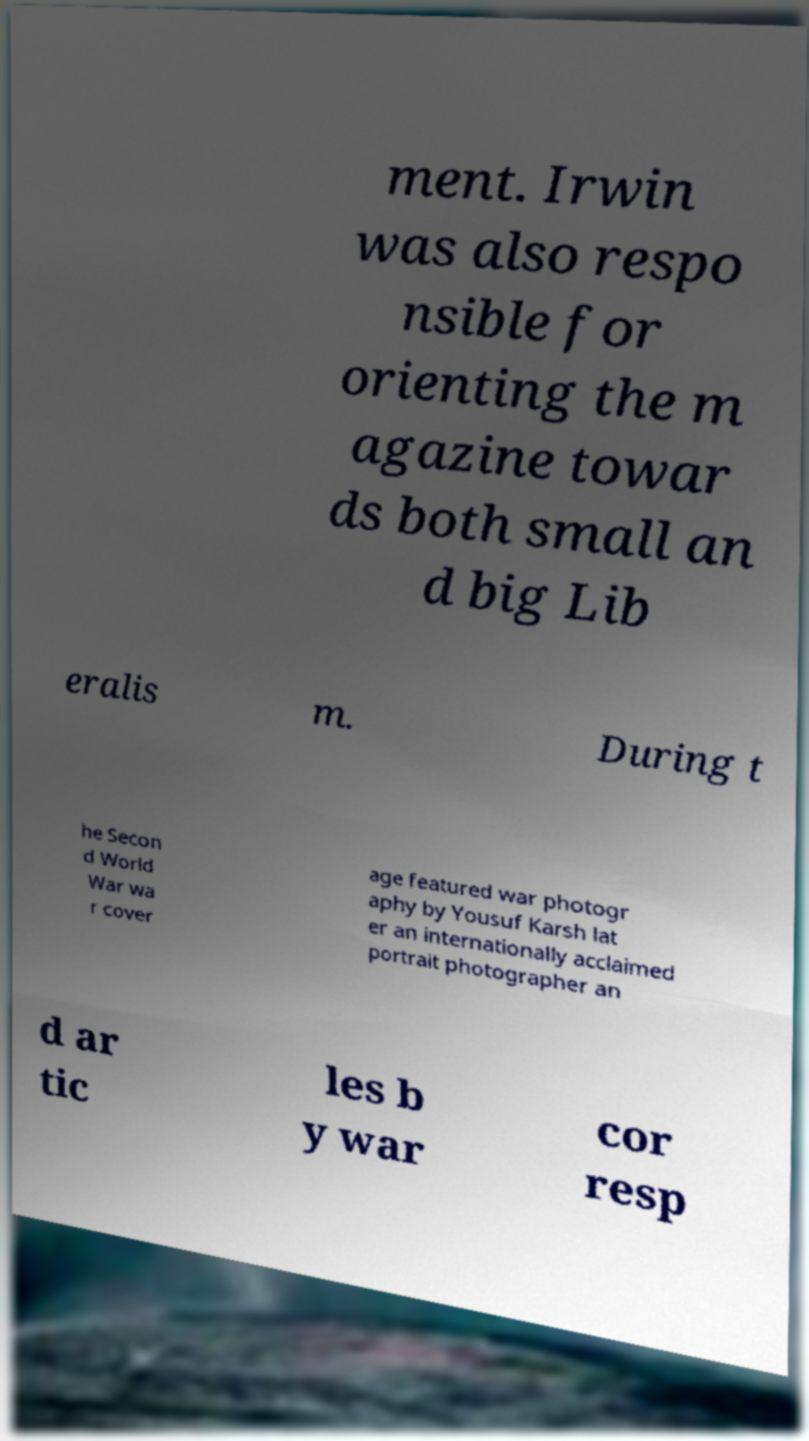Please read and relay the text visible in this image. What does it say? ment. Irwin was also respo nsible for orienting the m agazine towar ds both small an d big Lib eralis m. During t he Secon d World War wa r cover age featured war photogr aphy by Yousuf Karsh lat er an internationally acclaimed portrait photographer an d ar tic les b y war cor resp 